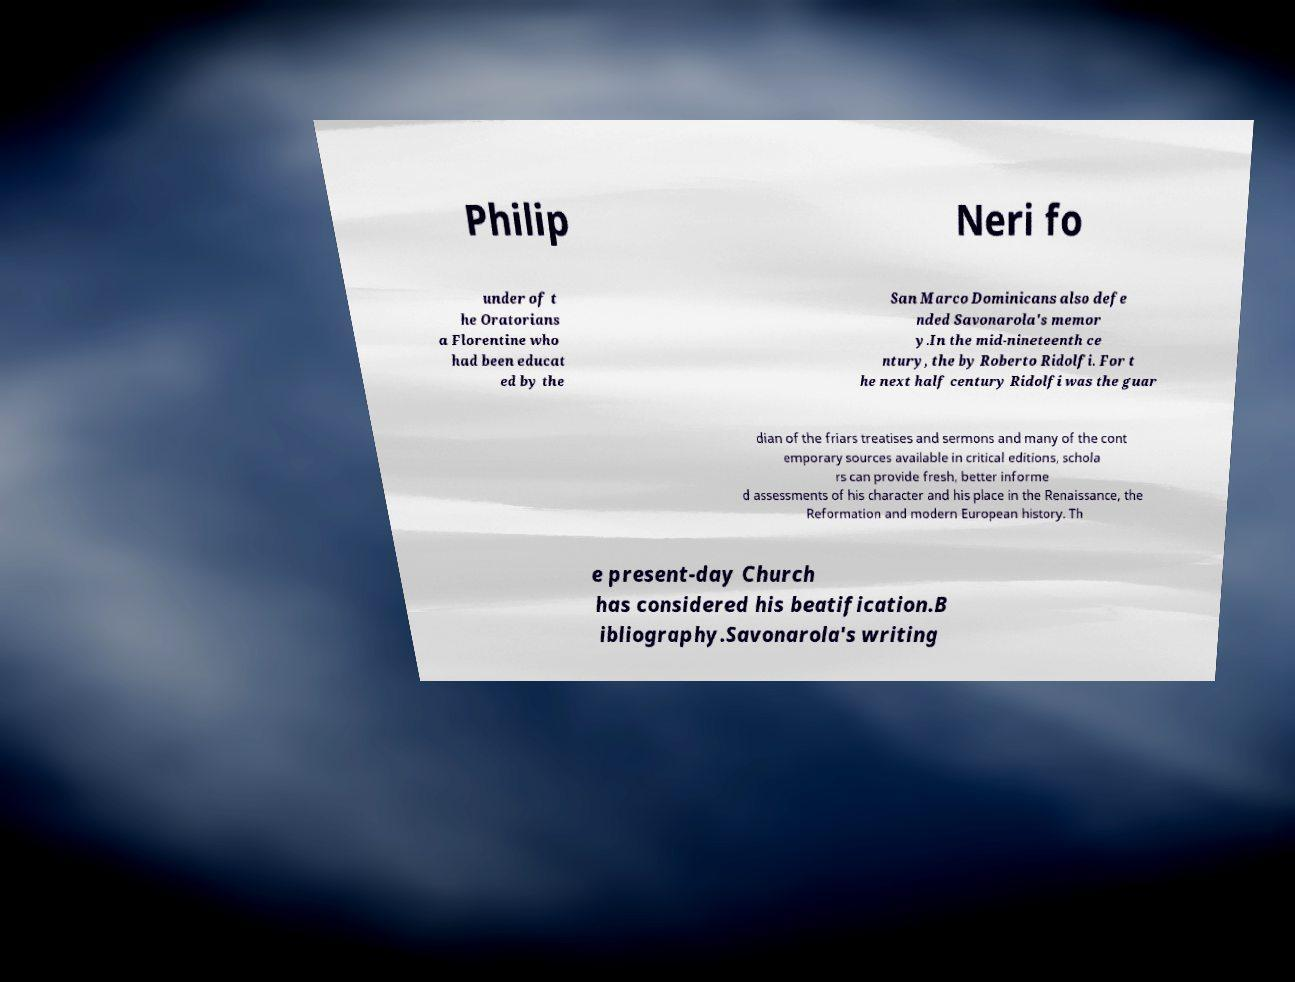Please read and relay the text visible in this image. What does it say? Philip Neri fo under of t he Oratorians a Florentine who had been educat ed by the San Marco Dominicans also defe nded Savonarola's memor y.In the mid-nineteenth ce ntury, the by Roberto Ridolfi. For t he next half century Ridolfi was the guar dian of the friars treatises and sermons and many of the cont emporary sources available in critical editions, schola rs can provide fresh, better informe d assessments of his character and his place in the Renaissance, the Reformation and modern European history. Th e present-day Church has considered his beatification.B ibliography.Savonarola's writing 